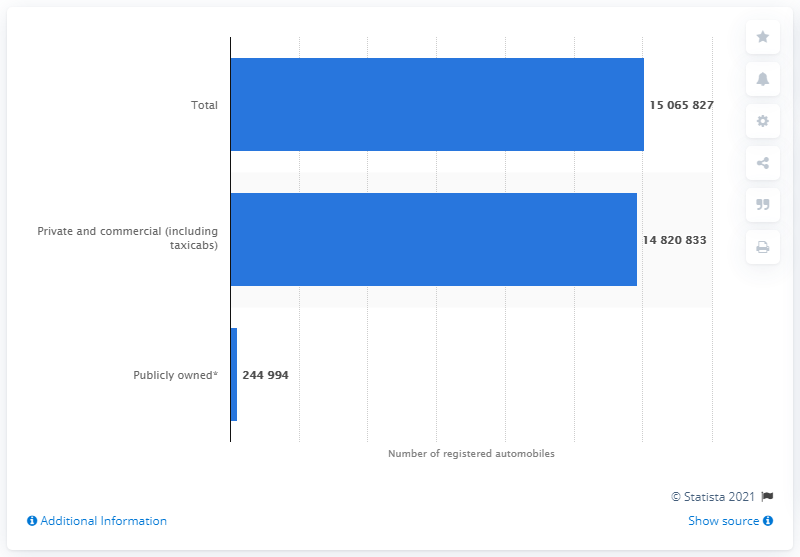Specify some key components in this picture. What is the difference between total and the maximum type of registered automobiles? In 2018, a total of 150,658,271 automobiles were registered in the state of California. In California in 2018, publicly owned vehicles were the type that were least registered. 